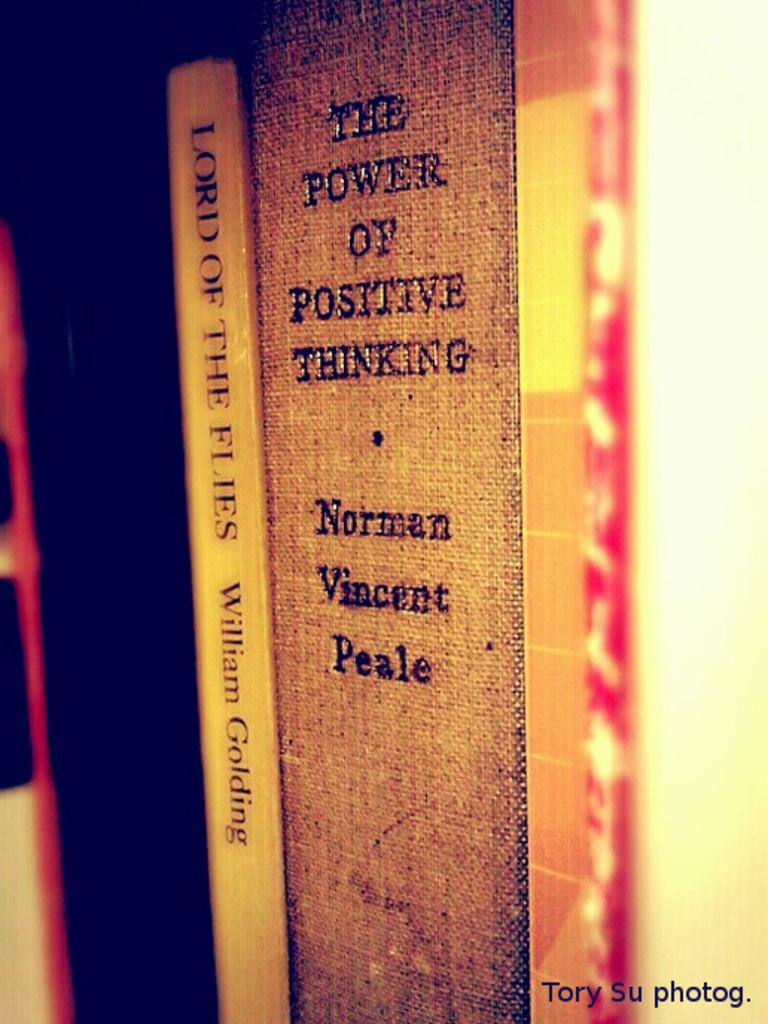Provide a one-sentence caption for the provided image. a picture with the spine of the power of positive thinking by norman vincent Peale. 